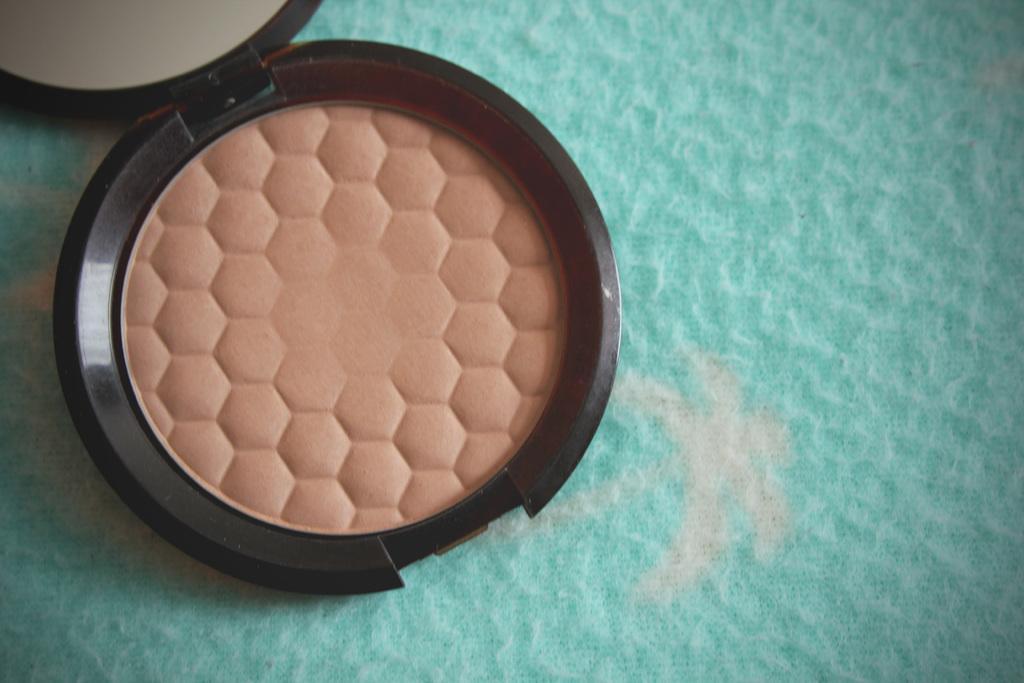How would you summarize this image in a sentence or two? In this picture I can see there is a face powder, I can see there is a mirror at the left side top corner and it is placed on the green surface. 